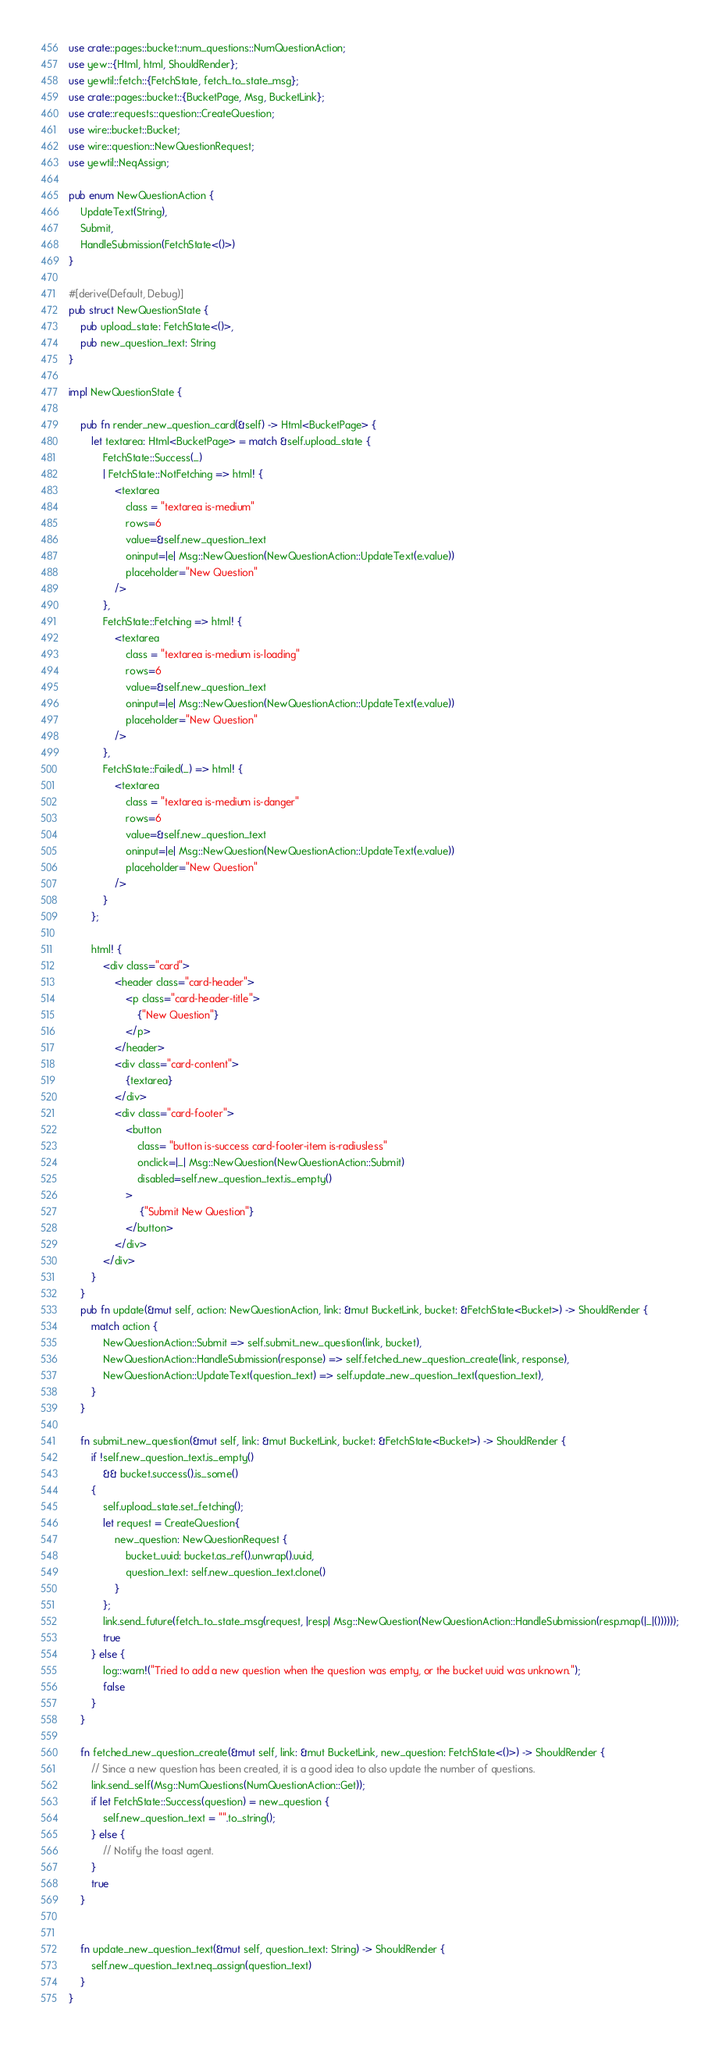Convert code to text. <code><loc_0><loc_0><loc_500><loc_500><_Rust_>use crate::pages::bucket::num_questions::NumQuestionAction;
use yew::{Html, html, ShouldRender};
use yewtil::fetch::{FetchState, fetch_to_state_msg};
use crate::pages::bucket::{BucketPage, Msg, BucketLink};
use crate::requests::question::CreateQuestion;
use wire::bucket::Bucket;
use wire::question::NewQuestionRequest;
use yewtil::NeqAssign;

pub enum NewQuestionAction {
    UpdateText(String),
    Submit,
    HandleSubmission(FetchState<()>)
}

#[derive(Default, Debug)]
pub struct NewQuestionState {
    pub upload_state: FetchState<()>,
    pub new_question_text: String
}

impl NewQuestionState {

    pub fn render_new_question_card(&self) -> Html<BucketPage> {
        let textarea: Html<BucketPage> = match &self.upload_state {
            FetchState::Success(_)
            | FetchState::NotFetching => html! {
                <textarea
                    class = "textarea is-medium"
                    rows=6
                    value=&self.new_question_text
                    oninput=|e| Msg::NewQuestion(NewQuestionAction::UpdateText(e.value))
                    placeholder="New Question"
                />
            },
            FetchState::Fetching => html! {
                <textarea
                    class = "textarea is-medium is-loading"
                    rows=6
                    value=&self.new_question_text
                    oninput=|e| Msg::NewQuestion(NewQuestionAction::UpdateText(e.value))
                    placeholder="New Question"
                />
            },
            FetchState::Failed(_) => html! {
                <textarea
                    class = "textarea is-medium is-danger"
                    rows=6
                    value=&self.new_question_text
                    oninput=|e| Msg::NewQuestion(NewQuestionAction::UpdateText(e.value))
                    placeholder="New Question"
                />
            }
        };

        html! {
            <div class="card">
                <header class="card-header">
                    <p class="card-header-title">
                        {"New Question"}
                    </p>
                </header>
                <div class="card-content">
                    {textarea}
                </div>
                <div class="card-footer">
                    <button
                        class= "button is-success card-footer-item is-radiusless"
                        onclick=|_| Msg::NewQuestion(NewQuestionAction::Submit)
                        disabled=self.new_question_text.is_empty()
                    >
                         {"Submit New Question"}
                    </button>
                </div>
            </div>
        }
    }
    pub fn update(&mut self, action: NewQuestionAction, link: &mut BucketLink, bucket: &FetchState<Bucket>) -> ShouldRender {
        match action {
            NewQuestionAction::Submit => self.submit_new_question(link, bucket),
            NewQuestionAction::HandleSubmission(response) => self.fetched_new_question_create(link, response),
            NewQuestionAction::UpdateText(question_text) => self.update_new_question_text(question_text),
        }
    }

    fn submit_new_question(&mut self, link: &mut BucketLink, bucket: &FetchState<Bucket>) -> ShouldRender {
        if !self.new_question_text.is_empty()
            && bucket.success().is_some()
        {
            self.upload_state.set_fetching();
            let request = CreateQuestion{
                new_question: NewQuestionRequest {
                    bucket_uuid: bucket.as_ref().unwrap().uuid,
                    question_text: self.new_question_text.clone()
                }
            };
            link.send_future(fetch_to_state_msg(request, |resp| Msg::NewQuestion(NewQuestionAction::HandleSubmission(resp.map(|_|())))));
            true
        } else {
            log::warn!("Tried to add a new question when the question was empty, or the bucket uuid was unknown.");
            false
        }
    }

    fn fetched_new_question_create(&mut self, link: &mut BucketLink, new_question: FetchState<()>) -> ShouldRender {
        // Since a new question has been created, it is a good idea to also update the number of questions.
        link.send_self(Msg::NumQuestions(NumQuestionAction::Get));
        if let FetchState::Success(question) = new_question {
            self.new_question_text = "".to_string();
        } else {
            // Notify the toast agent.
        }
        true
    }


    fn update_new_question_text(&mut self, question_text: String) -> ShouldRender {
        self.new_question_text.neq_assign(question_text)
    }
}</code> 